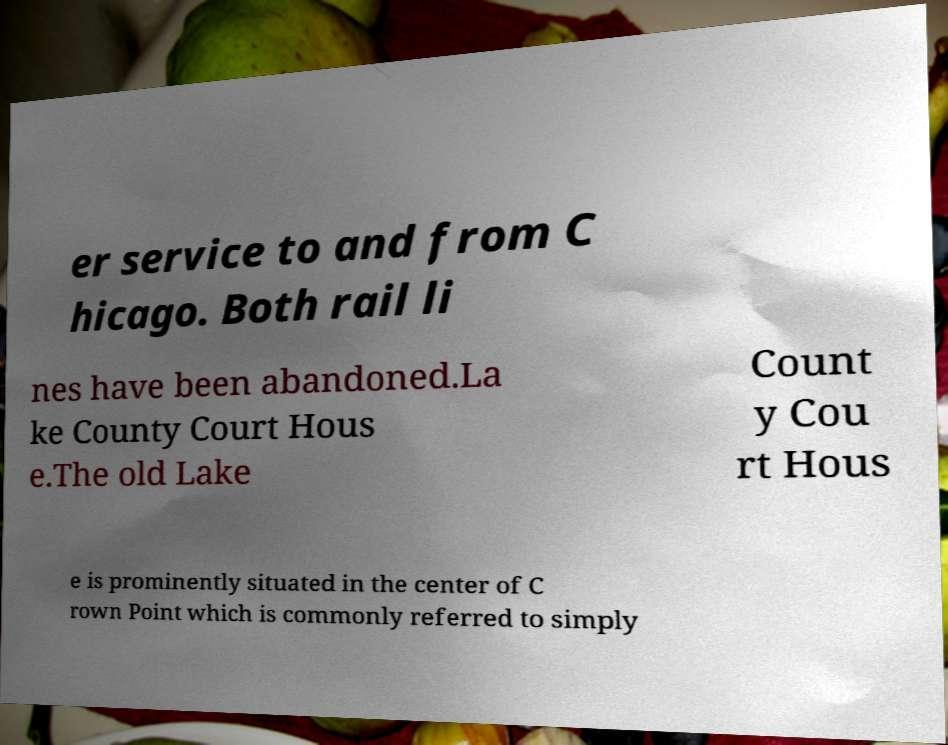Please read and relay the text visible in this image. What does it say? er service to and from C hicago. Both rail li nes have been abandoned.La ke County Court Hous e.The old Lake Count y Cou rt Hous e is prominently situated in the center of C rown Point which is commonly referred to simply 